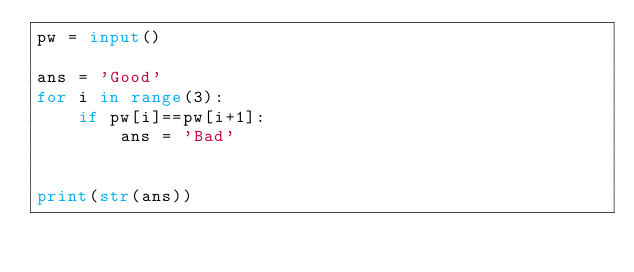<code> <loc_0><loc_0><loc_500><loc_500><_Python_>pw = input()

ans = 'Good'
for i in range(3):
    if pw[i]==pw[i+1]:
        ans = 'Bad'

        
print(str(ans))</code> 